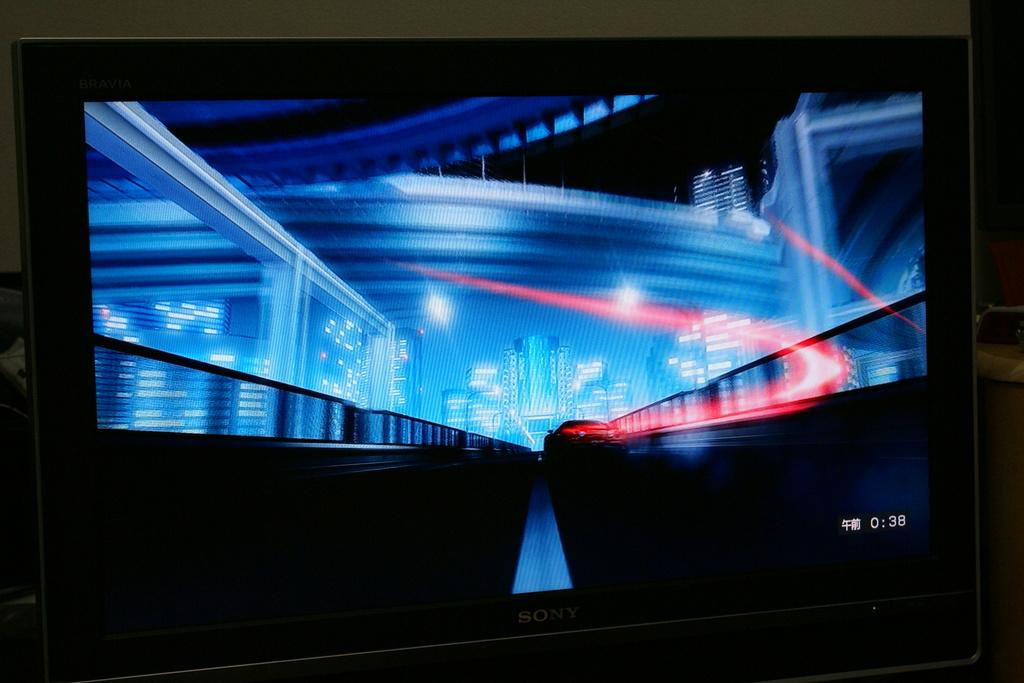<image>
Provide a brief description of the given image. A Sony tv showing a futuristic scene and 0:38 in the corner. 